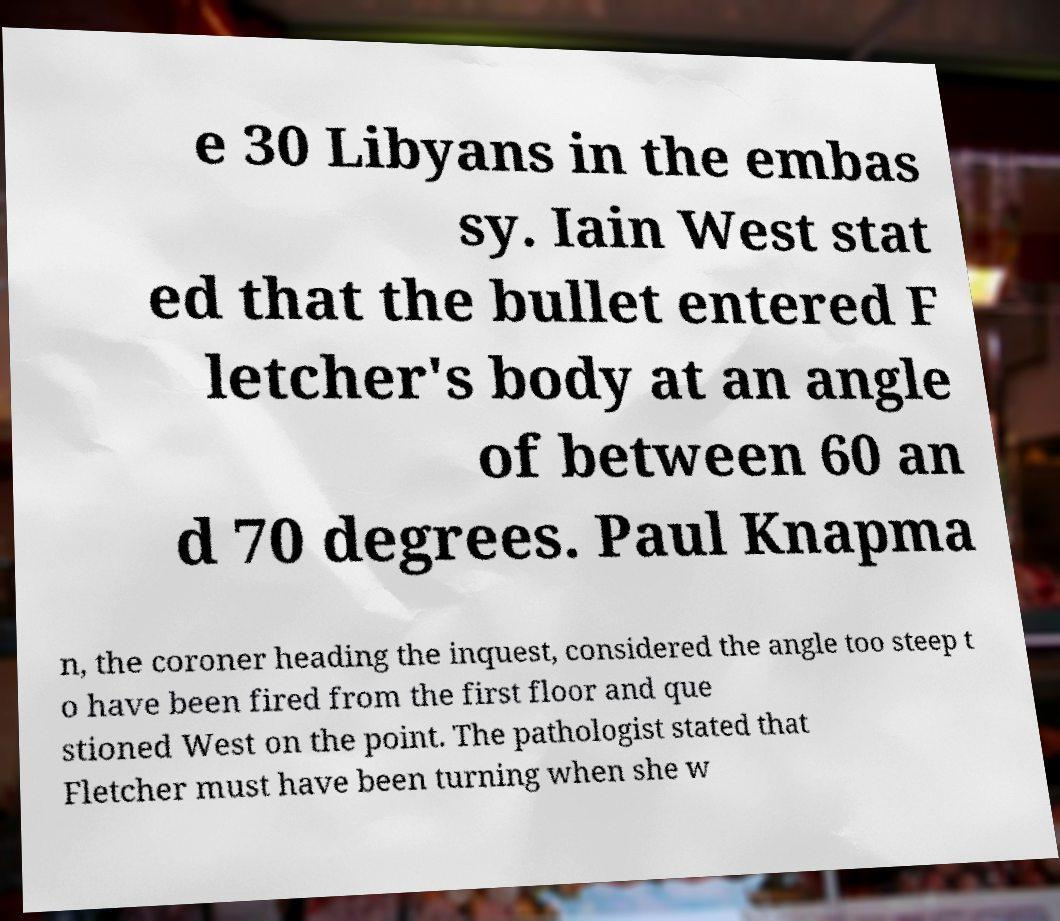For documentation purposes, I need the text within this image transcribed. Could you provide that? e 30 Libyans in the embas sy. Iain West stat ed that the bullet entered F letcher's body at an angle of between 60 an d 70 degrees. Paul Knapma n, the coroner heading the inquest, considered the angle too steep t o have been fired from the first floor and que stioned West on the point. The pathologist stated that Fletcher must have been turning when she w 